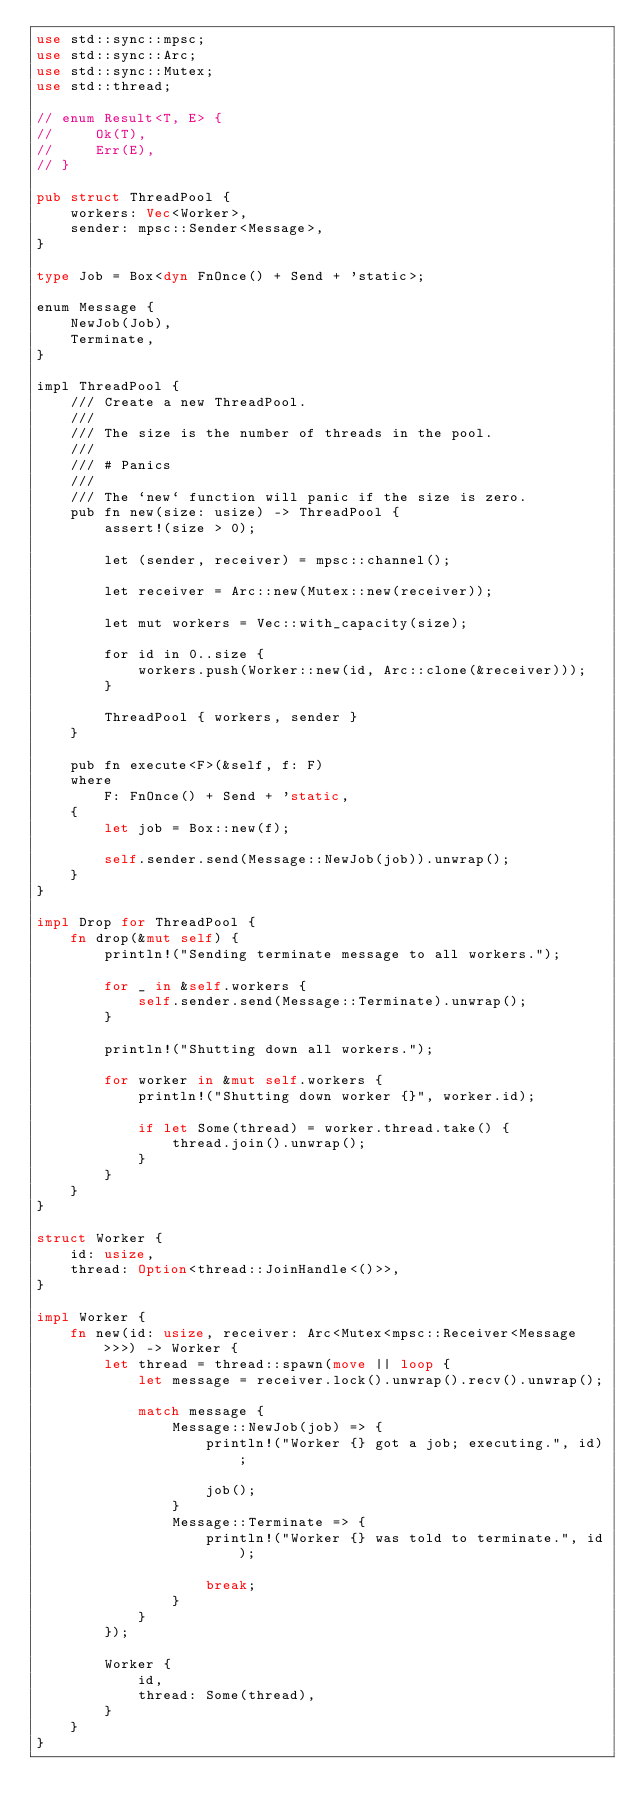Convert code to text. <code><loc_0><loc_0><loc_500><loc_500><_Rust_>use std::sync::mpsc;
use std::sync::Arc;
use std::sync::Mutex;
use std::thread;

// enum Result<T, E> {
//     Ok(T),
//     Err(E),
// }

pub struct ThreadPool {
    workers: Vec<Worker>,
    sender: mpsc::Sender<Message>,
}

type Job = Box<dyn FnOnce() + Send + 'static>;

enum Message {
    NewJob(Job),
    Terminate,
}

impl ThreadPool {
    /// Create a new ThreadPool.
    ///
    /// The size is the number of threads in the pool.
    ///
    /// # Panics
    ///
    /// The `new` function will panic if the size is zero.
    pub fn new(size: usize) -> ThreadPool {
        assert!(size > 0);

        let (sender, receiver) = mpsc::channel();

        let receiver = Arc::new(Mutex::new(receiver));

        let mut workers = Vec::with_capacity(size);

        for id in 0..size {
            workers.push(Worker::new(id, Arc::clone(&receiver)));
        }

        ThreadPool { workers, sender }
    }

    pub fn execute<F>(&self, f: F)
    where
        F: FnOnce() + Send + 'static,
    {
        let job = Box::new(f);

        self.sender.send(Message::NewJob(job)).unwrap();
    }
}

impl Drop for ThreadPool {
    fn drop(&mut self) {
        println!("Sending terminate message to all workers.");

        for _ in &self.workers {
            self.sender.send(Message::Terminate).unwrap();
        }

        println!("Shutting down all workers.");

        for worker in &mut self.workers {
            println!("Shutting down worker {}", worker.id);

            if let Some(thread) = worker.thread.take() {
                thread.join().unwrap();
            }
        }
    }
}

struct Worker {
    id: usize,
    thread: Option<thread::JoinHandle<()>>,
}

impl Worker {
    fn new(id: usize, receiver: Arc<Mutex<mpsc::Receiver<Message>>>) -> Worker {
        let thread = thread::spawn(move || loop {
            let message = receiver.lock().unwrap().recv().unwrap();

            match message {
                Message::NewJob(job) => {
                    println!("Worker {} got a job; executing.", id);

                    job();
                }
                Message::Terminate => {
                    println!("Worker {} was told to terminate.", id);

                    break;
                }
            }
        });

        Worker {
            id,
            thread: Some(thread),
        }
    }
}</code> 